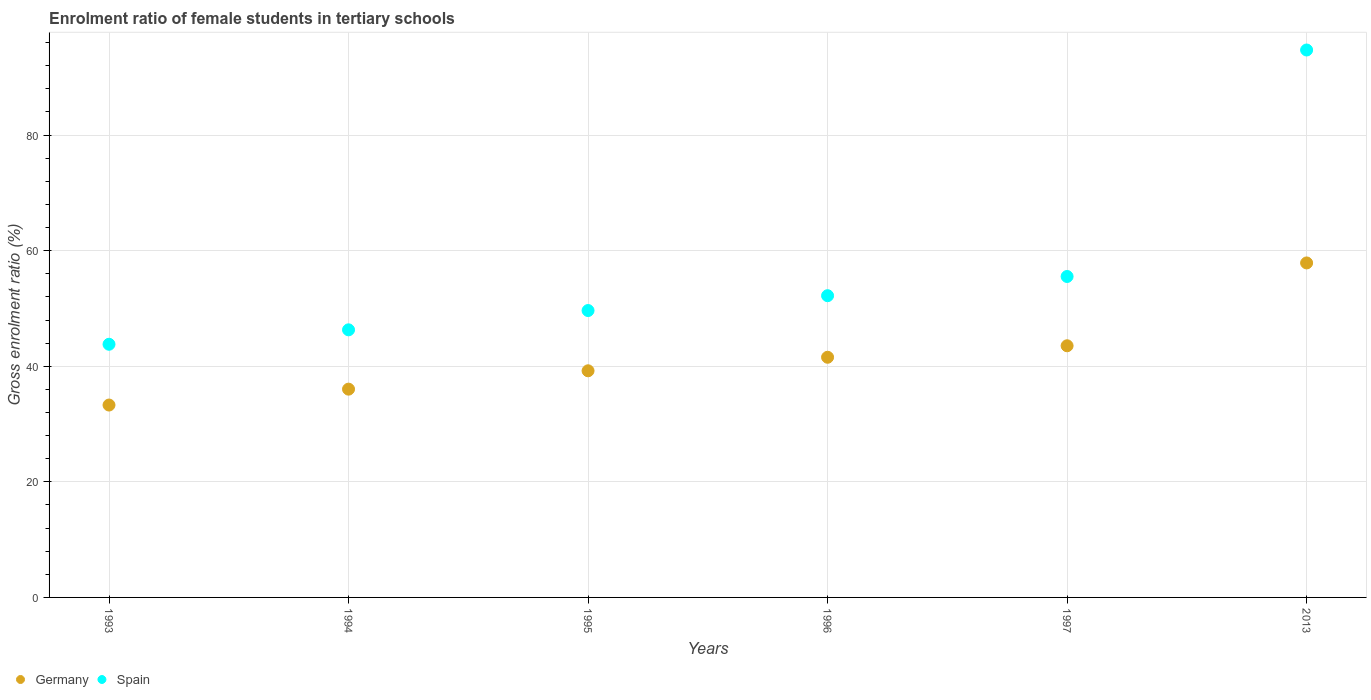How many different coloured dotlines are there?
Give a very brief answer. 2. Is the number of dotlines equal to the number of legend labels?
Your answer should be very brief. Yes. What is the enrolment ratio of female students in tertiary schools in Germany in 1995?
Offer a terse response. 39.21. Across all years, what is the maximum enrolment ratio of female students in tertiary schools in Germany?
Provide a short and direct response. 57.87. Across all years, what is the minimum enrolment ratio of female students in tertiary schools in Spain?
Keep it short and to the point. 43.8. In which year was the enrolment ratio of female students in tertiary schools in Germany maximum?
Offer a very short reply. 2013. What is the total enrolment ratio of female students in tertiary schools in Spain in the graph?
Ensure brevity in your answer.  342.2. What is the difference between the enrolment ratio of female students in tertiary schools in Germany in 1995 and that in 2013?
Offer a very short reply. -18.66. What is the difference between the enrolment ratio of female students in tertiary schools in Germany in 1994 and the enrolment ratio of female students in tertiary schools in Spain in 2013?
Make the answer very short. -58.68. What is the average enrolment ratio of female students in tertiary schools in Spain per year?
Make the answer very short. 57.03. In the year 1997, what is the difference between the enrolment ratio of female students in tertiary schools in Spain and enrolment ratio of female students in tertiary schools in Germany?
Make the answer very short. 11.99. What is the ratio of the enrolment ratio of female students in tertiary schools in Germany in 1993 to that in 1997?
Offer a very short reply. 0.76. Is the enrolment ratio of female students in tertiary schools in Spain in 1993 less than that in 1995?
Make the answer very short. Yes. Is the difference between the enrolment ratio of female students in tertiary schools in Spain in 1995 and 1997 greater than the difference between the enrolment ratio of female students in tertiary schools in Germany in 1995 and 1997?
Your answer should be compact. No. What is the difference between the highest and the second highest enrolment ratio of female students in tertiary schools in Spain?
Offer a terse response. 39.19. What is the difference between the highest and the lowest enrolment ratio of female students in tertiary schools in Germany?
Ensure brevity in your answer.  24.59. In how many years, is the enrolment ratio of female students in tertiary schools in Spain greater than the average enrolment ratio of female students in tertiary schools in Spain taken over all years?
Your answer should be compact. 1. Is the sum of the enrolment ratio of female students in tertiary schools in Germany in 1996 and 1997 greater than the maximum enrolment ratio of female students in tertiary schools in Spain across all years?
Your answer should be compact. No. Is the enrolment ratio of female students in tertiary schools in Germany strictly less than the enrolment ratio of female students in tertiary schools in Spain over the years?
Offer a very short reply. Yes. What is the difference between two consecutive major ticks on the Y-axis?
Give a very brief answer. 20. Does the graph contain any zero values?
Offer a terse response. No. Where does the legend appear in the graph?
Your response must be concise. Bottom left. How many legend labels are there?
Provide a short and direct response. 2. How are the legend labels stacked?
Make the answer very short. Horizontal. What is the title of the graph?
Make the answer very short. Enrolment ratio of female students in tertiary schools. Does "Fiji" appear as one of the legend labels in the graph?
Offer a terse response. No. What is the label or title of the X-axis?
Your response must be concise. Years. What is the label or title of the Y-axis?
Offer a terse response. Gross enrolment ratio (%). What is the Gross enrolment ratio (%) in Germany in 1993?
Your response must be concise. 33.29. What is the Gross enrolment ratio (%) of Spain in 1993?
Your answer should be very brief. 43.8. What is the Gross enrolment ratio (%) in Germany in 1994?
Offer a very short reply. 36.04. What is the Gross enrolment ratio (%) of Spain in 1994?
Keep it short and to the point. 46.3. What is the Gross enrolment ratio (%) in Germany in 1995?
Offer a very short reply. 39.21. What is the Gross enrolment ratio (%) of Spain in 1995?
Keep it short and to the point. 49.64. What is the Gross enrolment ratio (%) in Germany in 1996?
Offer a very short reply. 41.56. What is the Gross enrolment ratio (%) of Spain in 1996?
Provide a succinct answer. 52.21. What is the Gross enrolment ratio (%) of Germany in 1997?
Give a very brief answer. 43.54. What is the Gross enrolment ratio (%) of Spain in 1997?
Keep it short and to the point. 55.53. What is the Gross enrolment ratio (%) of Germany in 2013?
Make the answer very short. 57.87. What is the Gross enrolment ratio (%) of Spain in 2013?
Make the answer very short. 94.72. Across all years, what is the maximum Gross enrolment ratio (%) in Germany?
Provide a succinct answer. 57.87. Across all years, what is the maximum Gross enrolment ratio (%) in Spain?
Your answer should be compact. 94.72. Across all years, what is the minimum Gross enrolment ratio (%) in Germany?
Offer a terse response. 33.29. Across all years, what is the minimum Gross enrolment ratio (%) in Spain?
Your response must be concise. 43.8. What is the total Gross enrolment ratio (%) in Germany in the graph?
Give a very brief answer. 251.51. What is the total Gross enrolment ratio (%) in Spain in the graph?
Make the answer very short. 342.2. What is the difference between the Gross enrolment ratio (%) in Germany in 1993 and that in 1994?
Provide a succinct answer. -2.75. What is the difference between the Gross enrolment ratio (%) in Spain in 1993 and that in 1994?
Make the answer very short. -2.5. What is the difference between the Gross enrolment ratio (%) in Germany in 1993 and that in 1995?
Offer a very short reply. -5.93. What is the difference between the Gross enrolment ratio (%) in Spain in 1993 and that in 1995?
Provide a short and direct response. -5.84. What is the difference between the Gross enrolment ratio (%) of Germany in 1993 and that in 1996?
Make the answer very short. -8.27. What is the difference between the Gross enrolment ratio (%) of Spain in 1993 and that in 1996?
Ensure brevity in your answer.  -8.4. What is the difference between the Gross enrolment ratio (%) in Germany in 1993 and that in 1997?
Offer a terse response. -10.25. What is the difference between the Gross enrolment ratio (%) in Spain in 1993 and that in 1997?
Your response must be concise. -11.73. What is the difference between the Gross enrolment ratio (%) of Germany in 1993 and that in 2013?
Provide a succinct answer. -24.59. What is the difference between the Gross enrolment ratio (%) of Spain in 1993 and that in 2013?
Provide a succinct answer. -50.91. What is the difference between the Gross enrolment ratio (%) of Germany in 1994 and that in 1995?
Offer a very short reply. -3.18. What is the difference between the Gross enrolment ratio (%) of Spain in 1994 and that in 1995?
Your answer should be very brief. -3.34. What is the difference between the Gross enrolment ratio (%) in Germany in 1994 and that in 1996?
Provide a succinct answer. -5.52. What is the difference between the Gross enrolment ratio (%) of Spain in 1994 and that in 1996?
Make the answer very short. -5.91. What is the difference between the Gross enrolment ratio (%) in Germany in 1994 and that in 1997?
Keep it short and to the point. -7.51. What is the difference between the Gross enrolment ratio (%) of Spain in 1994 and that in 1997?
Offer a terse response. -9.23. What is the difference between the Gross enrolment ratio (%) of Germany in 1994 and that in 2013?
Your answer should be very brief. -21.84. What is the difference between the Gross enrolment ratio (%) in Spain in 1994 and that in 2013?
Keep it short and to the point. -48.42. What is the difference between the Gross enrolment ratio (%) of Germany in 1995 and that in 1996?
Make the answer very short. -2.34. What is the difference between the Gross enrolment ratio (%) in Spain in 1995 and that in 1996?
Your answer should be very brief. -2.57. What is the difference between the Gross enrolment ratio (%) in Germany in 1995 and that in 1997?
Your answer should be very brief. -4.33. What is the difference between the Gross enrolment ratio (%) of Spain in 1995 and that in 1997?
Provide a short and direct response. -5.89. What is the difference between the Gross enrolment ratio (%) in Germany in 1995 and that in 2013?
Your response must be concise. -18.66. What is the difference between the Gross enrolment ratio (%) in Spain in 1995 and that in 2013?
Your response must be concise. -45.08. What is the difference between the Gross enrolment ratio (%) in Germany in 1996 and that in 1997?
Give a very brief answer. -1.99. What is the difference between the Gross enrolment ratio (%) of Spain in 1996 and that in 1997?
Your response must be concise. -3.32. What is the difference between the Gross enrolment ratio (%) of Germany in 1996 and that in 2013?
Your answer should be very brief. -16.32. What is the difference between the Gross enrolment ratio (%) of Spain in 1996 and that in 2013?
Ensure brevity in your answer.  -42.51. What is the difference between the Gross enrolment ratio (%) in Germany in 1997 and that in 2013?
Offer a terse response. -14.33. What is the difference between the Gross enrolment ratio (%) of Spain in 1997 and that in 2013?
Make the answer very short. -39.19. What is the difference between the Gross enrolment ratio (%) in Germany in 1993 and the Gross enrolment ratio (%) in Spain in 1994?
Make the answer very short. -13.01. What is the difference between the Gross enrolment ratio (%) in Germany in 1993 and the Gross enrolment ratio (%) in Spain in 1995?
Ensure brevity in your answer.  -16.35. What is the difference between the Gross enrolment ratio (%) in Germany in 1993 and the Gross enrolment ratio (%) in Spain in 1996?
Give a very brief answer. -18.92. What is the difference between the Gross enrolment ratio (%) of Germany in 1993 and the Gross enrolment ratio (%) of Spain in 1997?
Provide a succinct answer. -22.24. What is the difference between the Gross enrolment ratio (%) of Germany in 1993 and the Gross enrolment ratio (%) of Spain in 2013?
Your answer should be compact. -61.43. What is the difference between the Gross enrolment ratio (%) of Germany in 1994 and the Gross enrolment ratio (%) of Spain in 1995?
Ensure brevity in your answer.  -13.6. What is the difference between the Gross enrolment ratio (%) in Germany in 1994 and the Gross enrolment ratio (%) in Spain in 1996?
Your answer should be very brief. -16.17. What is the difference between the Gross enrolment ratio (%) in Germany in 1994 and the Gross enrolment ratio (%) in Spain in 1997?
Make the answer very short. -19.49. What is the difference between the Gross enrolment ratio (%) in Germany in 1994 and the Gross enrolment ratio (%) in Spain in 2013?
Your answer should be compact. -58.68. What is the difference between the Gross enrolment ratio (%) in Germany in 1995 and the Gross enrolment ratio (%) in Spain in 1996?
Provide a succinct answer. -12.99. What is the difference between the Gross enrolment ratio (%) in Germany in 1995 and the Gross enrolment ratio (%) in Spain in 1997?
Offer a terse response. -16.32. What is the difference between the Gross enrolment ratio (%) in Germany in 1995 and the Gross enrolment ratio (%) in Spain in 2013?
Offer a very short reply. -55.5. What is the difference between the Gross enrolment ratio (%) of Germany in 1996 and the Gross enrolment ratio (%) of Spain in 1997?
Your response must be concise. -13.98. What is the difference between the Gross enrolment ratio (%) of Germany in 1996 and the Gross enrolment ratio (%) of Spain in 2013?
Keep it short and to the point. -53.16. What is the difference between the Gross enrolment ratio (%) in Germany in 1997 and the Gross enrolment ratio (%) in Spain in 2013?
Provide a short and direct response. -51.18. What is the average Gross enrolment ratio (%) in Germany per year?
Your answer should be compact. 41.92. What is the average Gross enrolment ratio (%) in Spain per year?
Make the answer very short. 57.03. In the year 1993, what is the difference between the Gross enrolment ratio (%) in Germany and Gross enrolment ratio (%) in Spain?
Offer a terse response. -10.52. In the year 1994, what is the difference between the Gross enrolment ratio (%) in Germany and Gross enrolment ratio (%) in Spain?
Provide a succinct answer. -10.26. In the year 1995, what is the difference between the Gross enrolment ratio (%) in Germany and Gross enrolment ratio (%) in Spain?
Offer a very short reply. -10.43. In the year 1996, what is the difference between the Gross enrolment ratio (%) in Germany and Gross enrolment ratio (%) in Spain?
Provide a short and direct response. -10.65. In the year 1997, what is the difference between the Gross enrolment ratio (%) in Germany and Gross enrolment ratio (%) in Spain?
Offer a very short reply. -11.99. In the year 2013, what is the difference between the Gross enrolment ratio (%) of Germany and Gross enrolment ratio (%) of Spain?
Offer a very short reply. -36.84. What is the ratio of the Gross enrolment ratio (%) of Germany in 1993 to that in 1994?
Keep it short and to the point. 0.92. What is the ratio of the Gross enrolment ratio (%) of Spain in 1993 to that in 1994?
Offer a very short reply. 0.95. What is the ratio of the Gross enrolment ratio (%) of Germany in 1993 to that in 1995?
Provide a short and direct response. 0.85. What is the ratio of the Gross enrolment ratio (%) of Spain in 1993 to that in 1995?
Offer a very short reply. 0.88. What is the ratio of the Gross enrolment ratio (%) of Germany in 1993 to that in 1996?
Provide a succinct answer. 0.8. What is the ratio of the Gross enrolment ratio (%) of Spain in 1993 to that in 1996?
Provide a succinct answer. 0.84. What is the ratio of the Gross enrolment ratio (%) in Germany in 1993 to that in 1997?
Ensure brevity in your answer.  0.76. What is the ratio of the Gross enrolment ratio (%) of Spain in 1993 to that in 1997?
Keep it short and to the point. 0.79. What is the ratio of the Gross enrolment ratio (%) in Germany in 1993 to that in 2013?
Keep it short and to the point. 0.58. What is the ratio of the Gross enrolment ratio (%) in Spain in 1993 to that in 2013?
Provide a succinct answer. 0.46. What is the ratio of the Gross enrolment ratio (%) of Germany in 1994 to that in 1995?
Make the answer very short. 0.92. What is the ratio of the Gross enrolment ratio (%) of Spain in 1994 to that in 1995?
Your answer should be compact. 0.93. What is the ratio of the Gross enrolment ratio (%) of Germany in 1994 to that in 1996?
Provide a succinct answer. 0.87. What is the ratio of the Gross enrolment ratio (%) of Spain in 1994 to that in 1996?
Provide a succinct answer. 0.89. What is the ratio of the Gross enrolment ratio (%) in Germany in 1994 to that in 1997?
Your answer should be compact. 0.83. What is the ratio of the Gross enrolment ratio (%) of Spain in 1994 to that in 1997?
Your response must be concise. 0.83. What is the ratio of the Gross enrolment ratio (%) in Germany in 1994 to that in 2013?
Your response must be concise. 0.62. What is the ratio of the Gross enrolment ratio (%) of Spain in 1994 to that in 2013?
Your answer should be very brief. 0.49. What is the ratio of the Gross enrolment ratio (%) of Germany in 1995 to that in 1996?
Ensure brevity in your answer.  0.94. What is the ratio of the Gross enrolment ratio (%) in Spain in 1995 to that in 1996?
Provide a short and direct response. 0.95. What is the ratio of the Gross enrolment ratio (%) of Germany in 1995 to that in 1997?
Your answer should be very brief. 0.9. What is the ratio of the Gross enrolment ratio (%) of Spain in 1995 to that in 1997?
Offer a terse response. 0.89. What is the ratio of the Gross enrolment ratio (%) of Germany in 1995 to that in 2013?
Keep it short and to the point. 0.68. What is the ratio of the Gross enrolment ratio (%) of Spain in 1995 to that in 2013?
Ensure brevity in your answer.  0.52. What is the ratio of the Gross enrolment ratio (%) in Germany in 1996 to that in 1997?
Provide a short and direct response. 0.95. What is the ratio of the Gross enrolment ratio (%) in Spain in 1996 to that in 1997?
Make the answer very short. 0.94. What is the ratio of the Gross enrolment ratio (%) of Germany in 1996 to that in 2013?
Give a very brief answer. 0.72. What is the ratio of the Gross enrolment ratio (%) in Spain in 1996 to that in 2013?
Make the answer very short. 0.55. What is the ratio of the Gross enrolment ratio (%) in Germany in 1997 to that in 2013?
Offer a very short reply. 0.75. What is the ratio of the Gross enrolment ratio (%) in Spain in 1997 to that in 2013?
Give a very brief answer. 0.59. What is the difference between the highest and the second highest Gross enrolment ratio (%) of Germany?
Ensure brevity in your answer.  14.33. What is the difference between the highest and the second highest Gross enrolment ratio (%) of Spain?
Your answer should be very brief. 39.19. What is the difference between the highest and the lowest Gross enrolment ratio (%) of Germany?
Offer a very short reply. 24.59. What is the difference between the highest and the lowest Gross enrolment ratio (%) of Spain?
Your response must be concise. 50.91. 